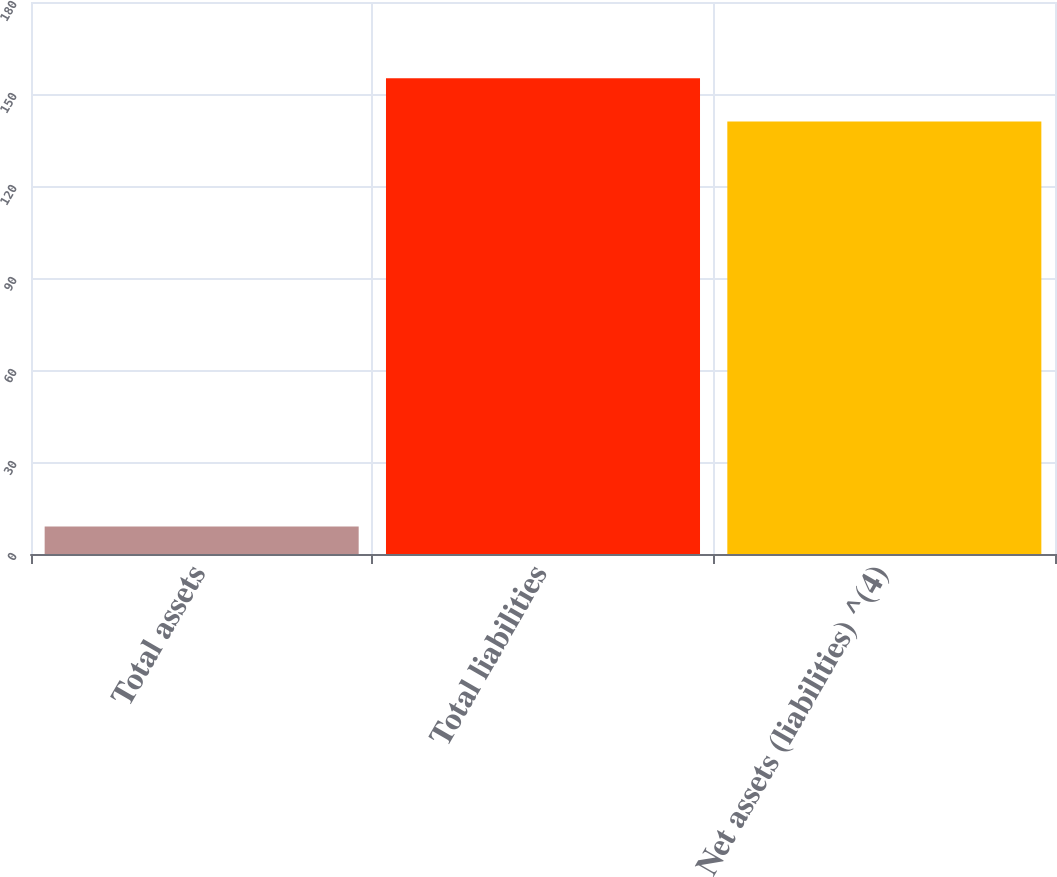<chart> <loc_0><loc_0><loc_500><loc_500><bar_chart><fcel>Total assets<fcel>Total liabilities<fcel>Net assets (liabilities) ^(4)<nl><fcel>9<fcel>155.1<fcel>141<nl></chart> 